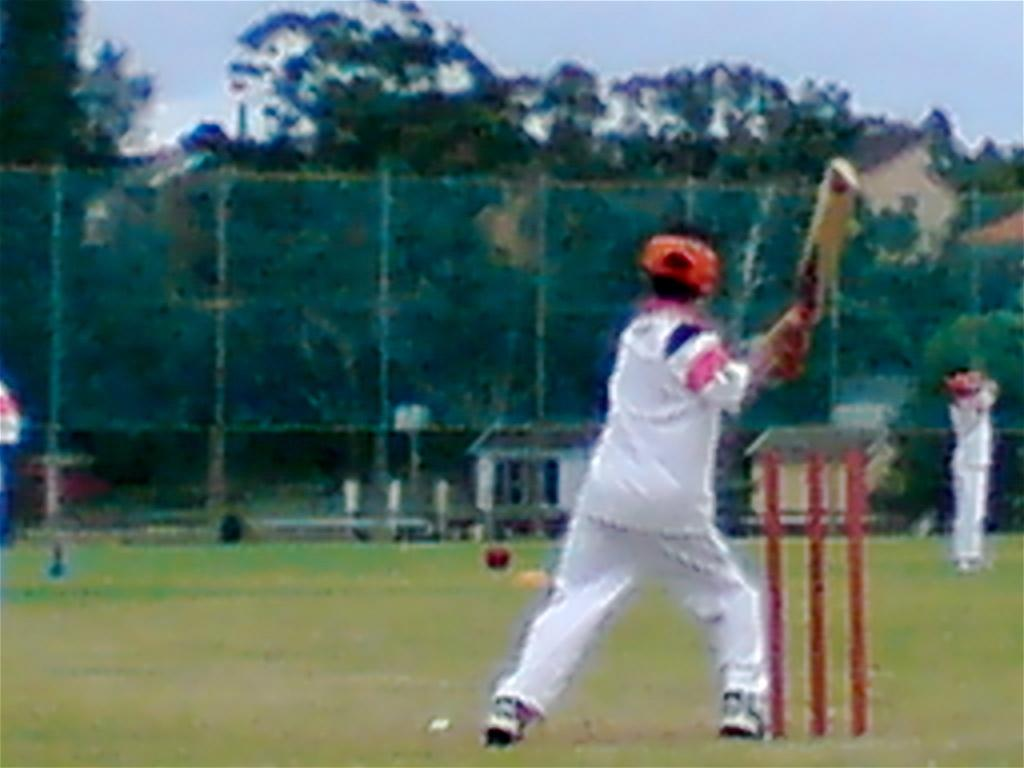Who is the main subject in the image? There is a man in the image. What is the man doing in the image? The man is playing cricket. What color is the dress the man is wearing? The man is wearing a white dress. What is present in the image to contain the cricket ball? There is a net in the image. What can be seen in the background of the image? There are trees in the background of the image. What type of milk is being used to water the plants in the image? There are no plants or milk present in the image; it features a man playing cricket with a net in the background. How many firemen are visible in the image? There are no firemen present in the image; it features a man playing cricket with a net in the background. 